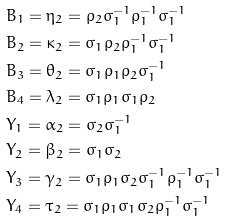<formula> <loc_0><loc_0><loc_500><loc_500>& B _ { 1 } = \eta _ { 2 } = \rho _ { 2 } \sigma _ { 1 } ^ { - 1 } \rho _ { 1 } ^ { - 1 } \sigma _ { 1 } ^ { - 1 } \\ & B _ { 2 } = \kappa _ { 2 } = \sigma _ { 1 } \rho _ { 2 } \rho _ { 1 } ^ { - 1 } \sigma _ { 1 } ^ { - 1 } \\ & B _ { 3 } = \theta _ { 2 } = \sigma _ { 1 } \rho _ { 1 } \rho _ { 2 } \sigma _ { 1 } ^ { - 1 } \\ & B _ { 4 } = \lambda _ { 2 } = \sigma _ { 1 } \rho _ { 1 } \sigma _ { 1 } \rho _ { 2 } \\ & Y _ { 1 } = \alpha _ { 2 } = \sigma _ { 2 } \sigma _ { 1 } ^ { - 1 } \\ & Y _ { 2 } = \beta _ { 2 } = \sigma _ { 1 } \sigma _ { 2 } \\ & Y _ { 3 } = \gamma _ { 2 } = \sigma _ { 1 } \rho _ { 1 } \sigma _ { 2 } \sigma _ { 1 } ^ { - 1 } \rho _ { 1 } ^ { - 1 } \sigma _ { 1 } ^ { - 1 } \\ & Y _ { 4 } = \tau _ { 2 } = \sigma _ { 1 } \rho _ { 1 } \sigma _ { 1 } \sigma _ { 2 } \rho _ { 1 } ^ { - 1 } \sigma _ { 1 } ^ { - 1 }</formula> 